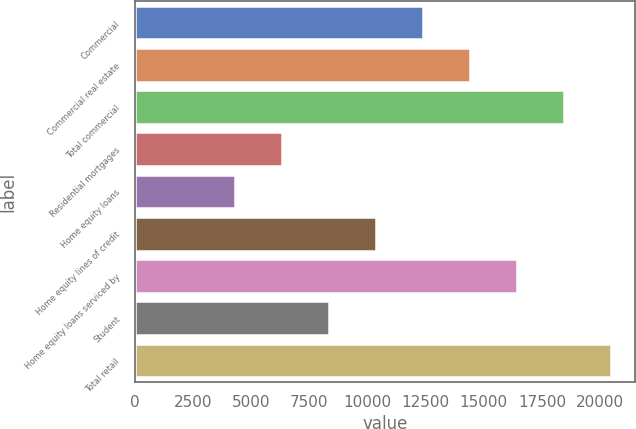<chart> <loc_0><loc_0><loc_500><loc_500><bar_chart><fcel>Commercial<fcel>Commercial real estate<fcel>Total commercial<fcel>Residential mortgages<fcel>Home equity loans<fcel>Home equity lines of credit<fcel>Home equity loans serviced by<fcel>Student<fcel>Total retail<nl><fcel>12379.8<fcel>14404.6<fcel>18454.2<fcel>6305.4<fcel>4280.6<fcel>10355<fcel>16429.4<fcel>8330.2<fcel>20479<nl></chart> 